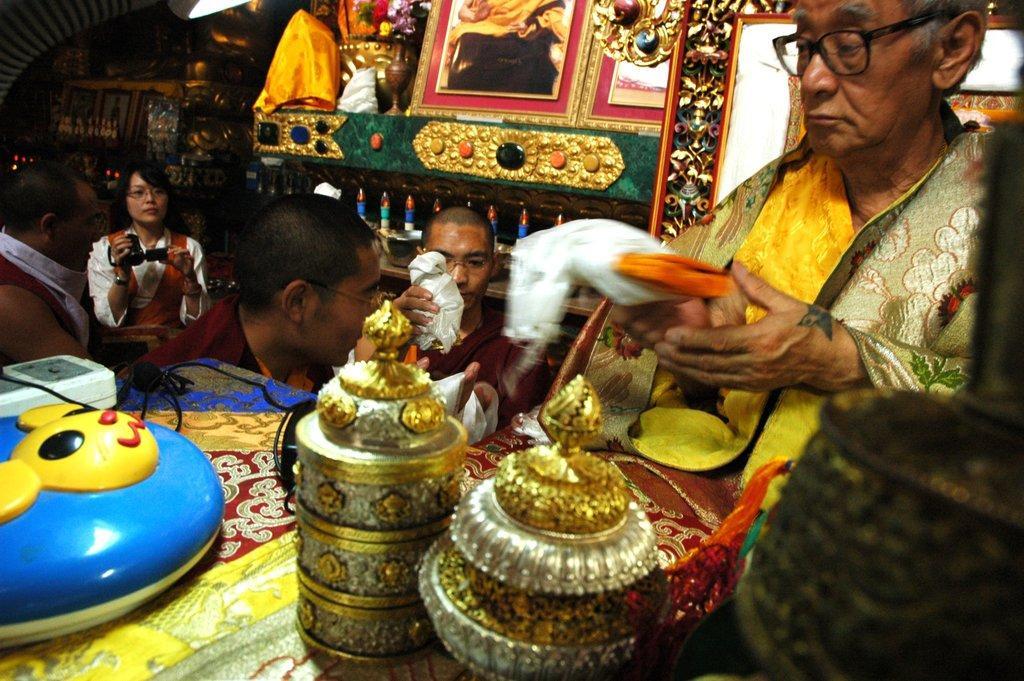Can you describe this image briefly? In this picture there are people, among them there is a woman holding a camera and we can see cables and few objects on the table. In the background of the image we can see frames, flowers in a vase and objects on the platform. 